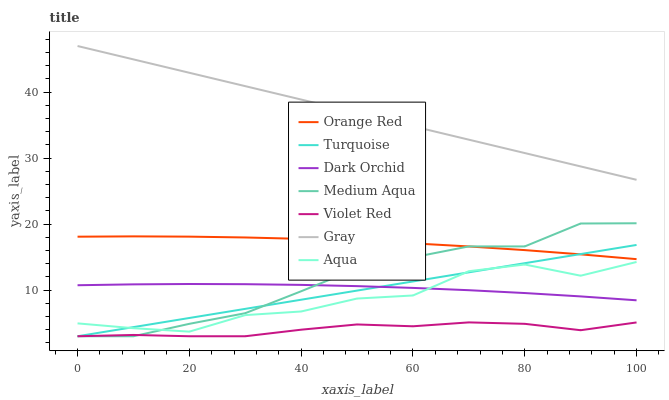Does Violet Red have the minimum area under the curve?
Answer yes or no. Yes. Does Gray have the maximum area under the curve?
Answer yes or no. Yes. Does Aqua have the minimum area under the curve?
Answer yes or no. No. Does Aqua have the maximum area under the curve?
Answer yes or no. No. Is Turquoise the smoothest?
Answer yes or no. Yes. Is Aqua the roughest?
Answer yes or no. Yes. Is Violet Red the smoothest?
Answer yes or no. No. Is Violet Red the roughest?
Answer yes or no. No. Does Violet Red have the lowest value?
Answer yes or no. Yes. Does Aqua have the lowest value?
Answer yes or no. No. Does Gray have the highest value?
Answer yes or no. Yes. Does Aqua have the highest value?
Answer yes or no. No. Is Aqua less than Orange Red?
Answer yes or no. Yes. Is Dark Orchid greater than Violet Red?
Answer yes or no. Yes. Does Medium Aqua intersect Aqua?
Answer yes or no. Yes. Is Medium Aqua less than Aqua?
Answer yes or no. No. Is Medium Aqua greater than Aqua?
Answer yes or no. No. Does Aqua intersect Orange Red?
Answer yes or no. No. 